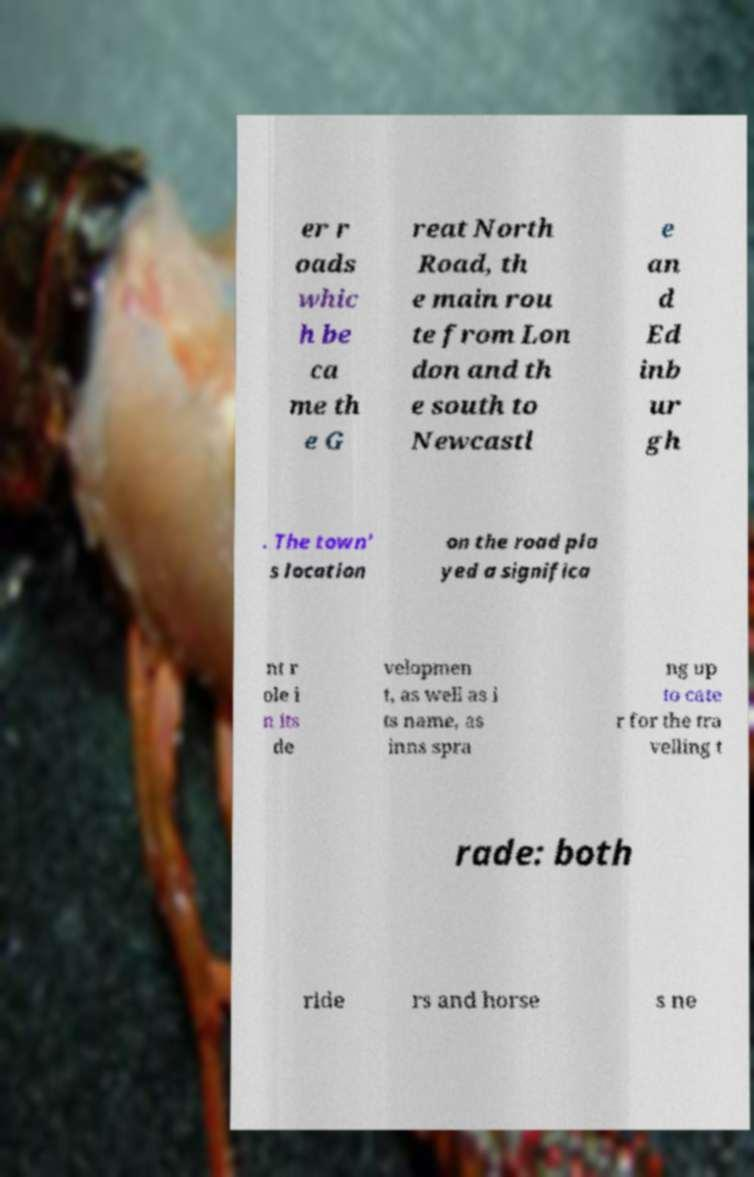Please read and relay the text visible in this image. What does it say? er r oads whic h be ca me th e G reat North Road, th e main rou te from Lon don and th e south to Newcastl e an d Ed inb ur gh . The town' s location on the road pla yed a significa nt r ole i n its de velopmen t, as well as i ts name, as inns spra ng up to cate r for the tra velling t rade: both ride rs and horse s ne 